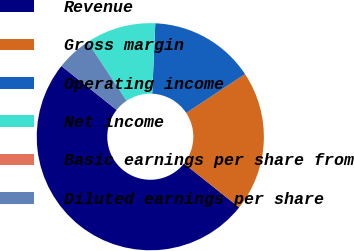Convert chart to OTSL. <chart><loc_0><loc_0><loc_500><loc_500><pie_chart><fcel>Revenue<fcel>Gross margin<fcel>Operating income<fcel>Net income<fcel>Basic earnings per share from<fcel>Diluted earnings per share<nl><fcel>50.0%<fcel>20.0%<fcel>15.0%<fcel>10.0%<fcel>0.0%<fcel>5.0%<nl></chart> 